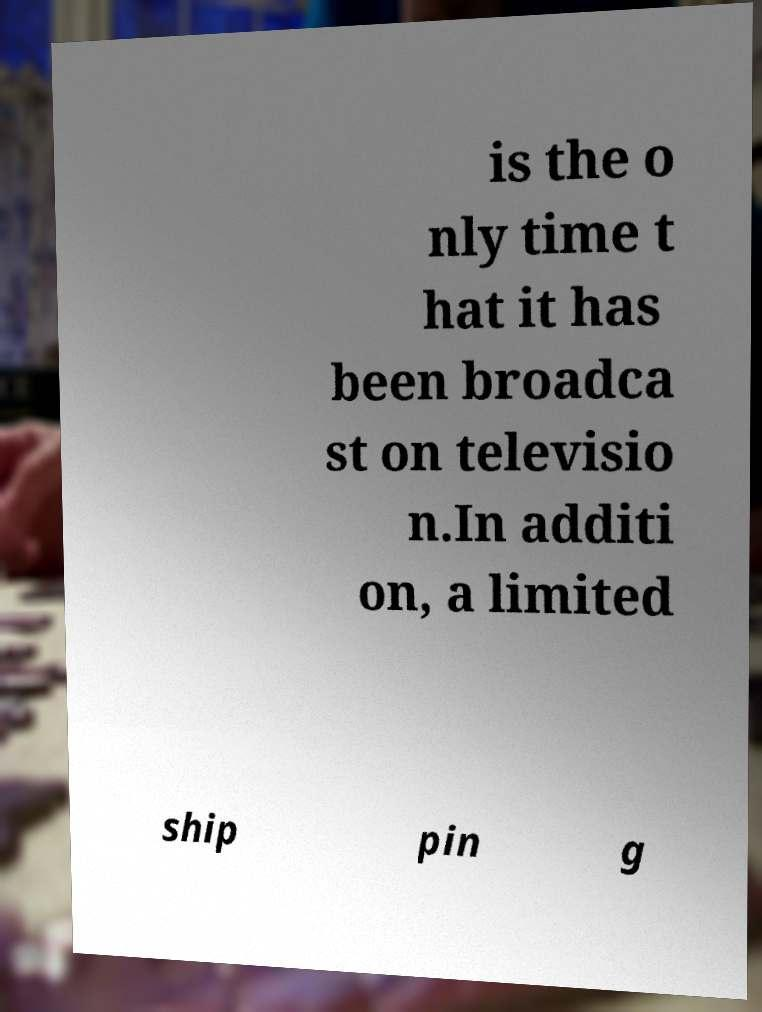Please read and relay the text visible in this image. What does it say? is the o nly time t hat it has been broadca st on televisio n.In additi on, a limited ship pin g 